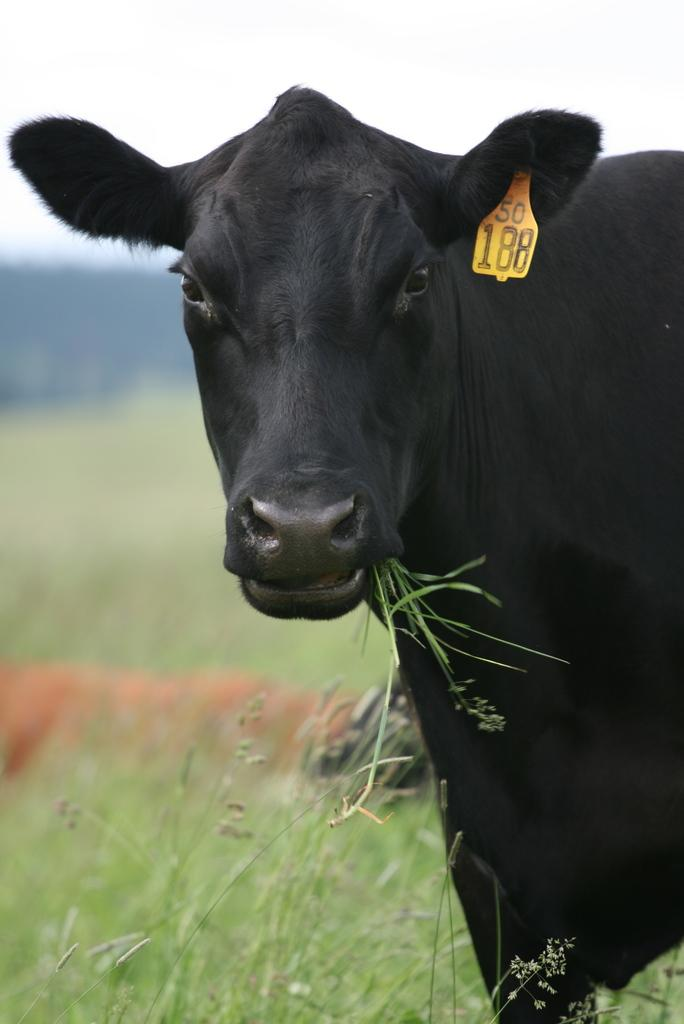What animal is present in the image? There is a cow in the image. What is the cow standing on? The cow is on grass. What can be seen in the background of the image? The sky is visible in the background of the image. Where might this image have been taken? The image may have been taken on a farm, given the presence of a cow and grass. What type of furniture can be seen in the image? There is no furniture present in the image; it features a cow on grass with the sky visible in the background. 